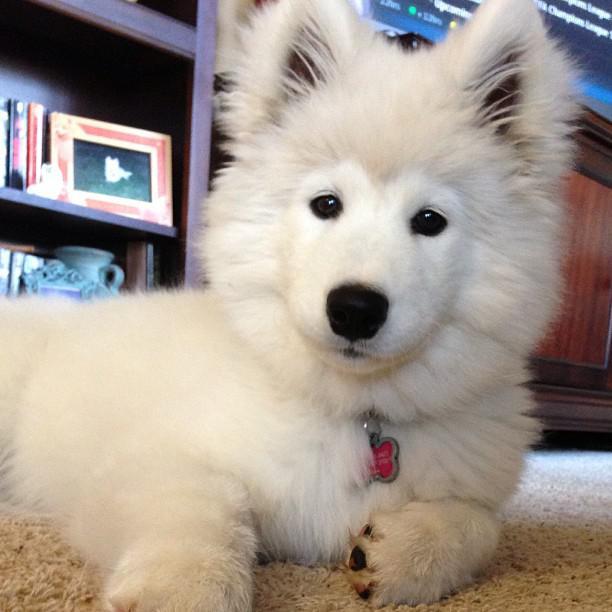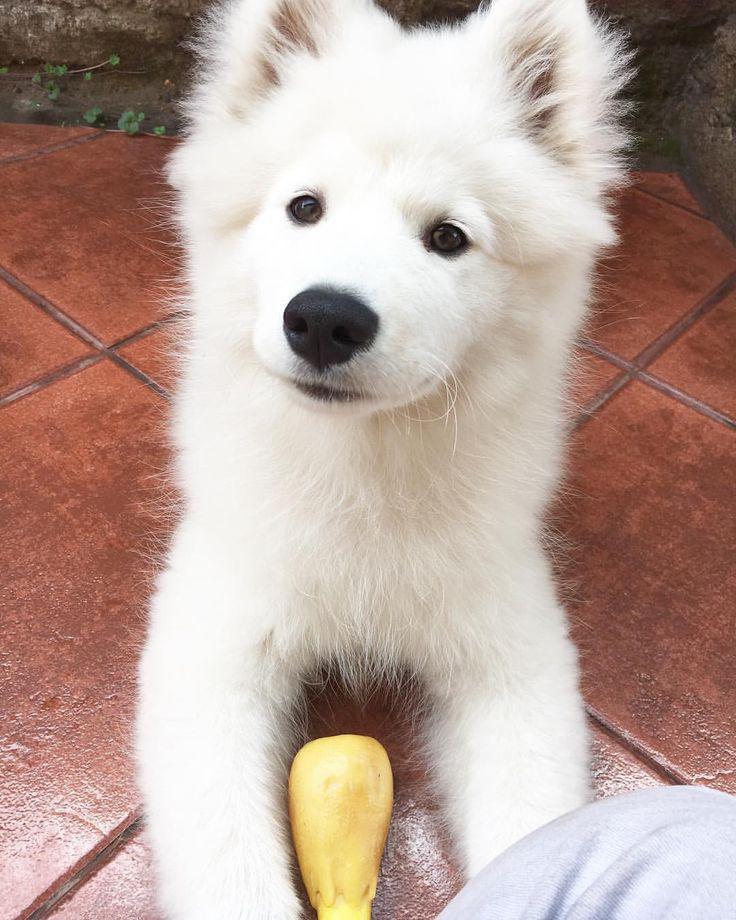The first image is the image on the left, the second image is the image on the right. Considering the images on both sides, is "There's at least one angry dog showing its teeth in the image pair." valid? Answer yes or no. No. The first image is the image on the left, the second image is the image on the right. Given the left and right images, does the statement "An image shows an open-mouthed white dog with tongue showing and a non-fierce expression." hold true? Answer yes or no. No. 